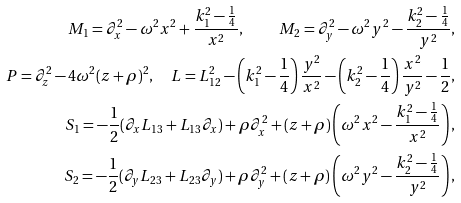<formula> <loc_0><loc_0><loc_500><loc_500>M _ { 1 } = \partial ^ { 2 } _ { x } - \omega ^ { 2 } x ^ { 2 } + \frac { k ^ { 2 } _ { 1 } - \frac { 1 } { 4 } } { x ^ { 2 } } , \quad M _ { 2 } = \partial ^ { 2 } _ { y } - \omega ^ { 2 } y ^ { 2 } - \frac { k ^ { 2 } _ { 2 } - \frac { 1 } { 4 } } { y ^ { 2 } } , \\ P = \partial ^ { 2 } _ { z } - 4 \omega ^ { 2 } ( z + \rho ) ^ { 2 } , \quad L = L ^ { 2 } _ { 1 2 } - \left ( k ^ { 2 } _ { 1 } - \frac { 1 } { 4 } \right ) \frac { y ^ { 2 } } { x ^ { 2 } } - \left ( k ^ { 2 } _ { 2 } - { \frac { 1 } { 4 } } \right ) \frac { x ^ { 2 } } { y ^ { 2 } } - { \frac { 1 } { 2 } } , \\ S _ { 1 } = - { \frac { 1 } { 2 } } ( \partial _ { x } L _ { 1 3 } + L _ { 1 3 } \partial _ { x } ) + \rho \partial ^ { 2 } _ { x } + ( z + \rho ) \left ( \omega ^ { 2 } x ^ { 2 } - \frac { k ^ { 2 } _ { 1 } - \frac { 1 } { 4 } } { x ^ { 2 } } \right ) , \\ S _ { 2 } = - { \frac { 1 } { 2 } } ( \partial _ { y } L _ { 2 3 } + L _ { 2 3 } \partial _ { y } ) + \rho \partial ^ { 2 } _ { y } + ( z + \rho ) \left ( \omega ^ { 2 } y ^ { 2 } - \frac { k ^ { 2 } _ { 2 } - \frac { 1 } { 4 } } { y ^ { 2 } } \right ) ,</formula> 